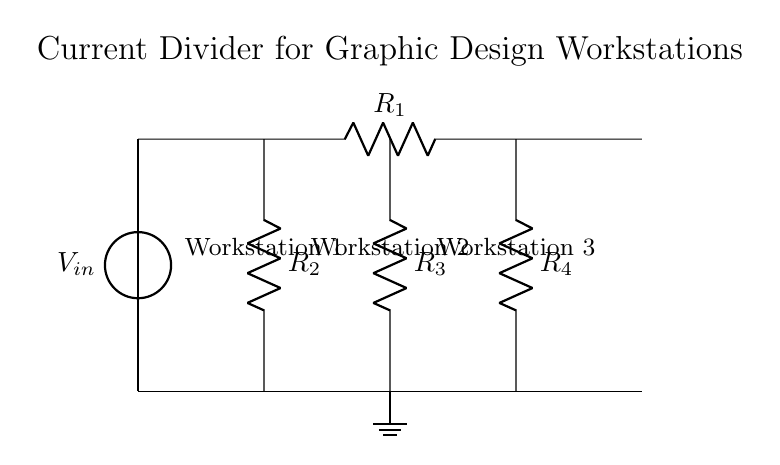What is the input voltage of the circuit? The input voltage is marked as V_in at the top of the circuit diagram. It is the source voltage that powers the entire circuit.
Answer: V_in How many resistors are present in the circuit? There are four resistors shown in the circuit diagram, labeled R1, R2, R3, and R4. Each resistor is represented as a distinct component along the current path and branches.
Answer: 4 Which resistors are connected in parallel? Resistors R2, R3, and R4 are connected in parallel because they share the same two nodes (top at the same voltage level and ground at the bottom) allowing current to divide between them.
Answer: R2, R3, R4 What is the purpose of the current divider? The current divider's purpose is to distribute the input current among the parallel branches (R2, R3, and R4) evenly or according to specific resistance values, allowing multiple workstations to be powered.
Answer: Distribute current If the value of R2 is twice that of R3, which resistor would have the highest current? In a current divider circuit, the branch with the lowest resistance receives the highest current. Since R2 has twice the resistance of R3, R3 will carry more current than R2.
Answer: R3 